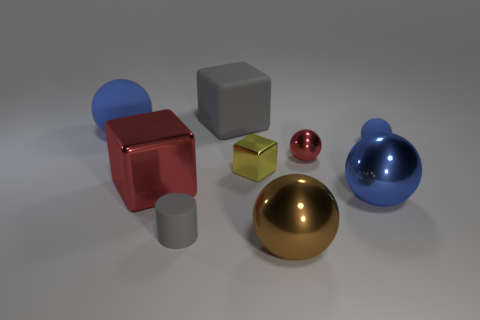Is the number of small red metallic objects behind the tiny red sphere greater than the number of brown balls on the right side of the small gray rubber cylinder?
Give a very brief answer. No. There is a shiny sphere that is both in front of the big red block and to the right of the brown object; what is its size?
Your response must be concise. Large. How many cubes are the same size as the gray rubber cylinder?
Give a very brief answer. 1. What material is the large block that is the same color as the small matte cylinder?
Offer a very short reply. Rubber. There is a rubber thing on the right side of the rubber block; does it have the same shape as the brown thing?
Your answer should be compact. Yes. Are there fewer big red shiny objects in front of the large blue metallic thing than tiny blue blocks?
Make the answer very short. No. Are there any big metallic spheres of the same color as the big rubber cube?
Make the answer very short. No. There is a tiny yellow metallic object; is its shape the same as the gray rubber thing that is on the right side of the gray rubber cylinder?
Your answer should be very brief. Yes. Are there any red things made of the same material as the small cylinder?
Your answer should be compact. No. There is a blue rubber object to the right of the gray object left of the large matte block; is there a tiny blue matte thing on the left side of it?
Offer a very short reply. No. 